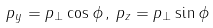Convert formula to latex. <formula><loc_0><loc_0><loc_500><loc_500>p _ { y } = p _ { \perp } \cos \phi \, , \, p _ { z } = p _ { \perp } \sin \phi</formula> 